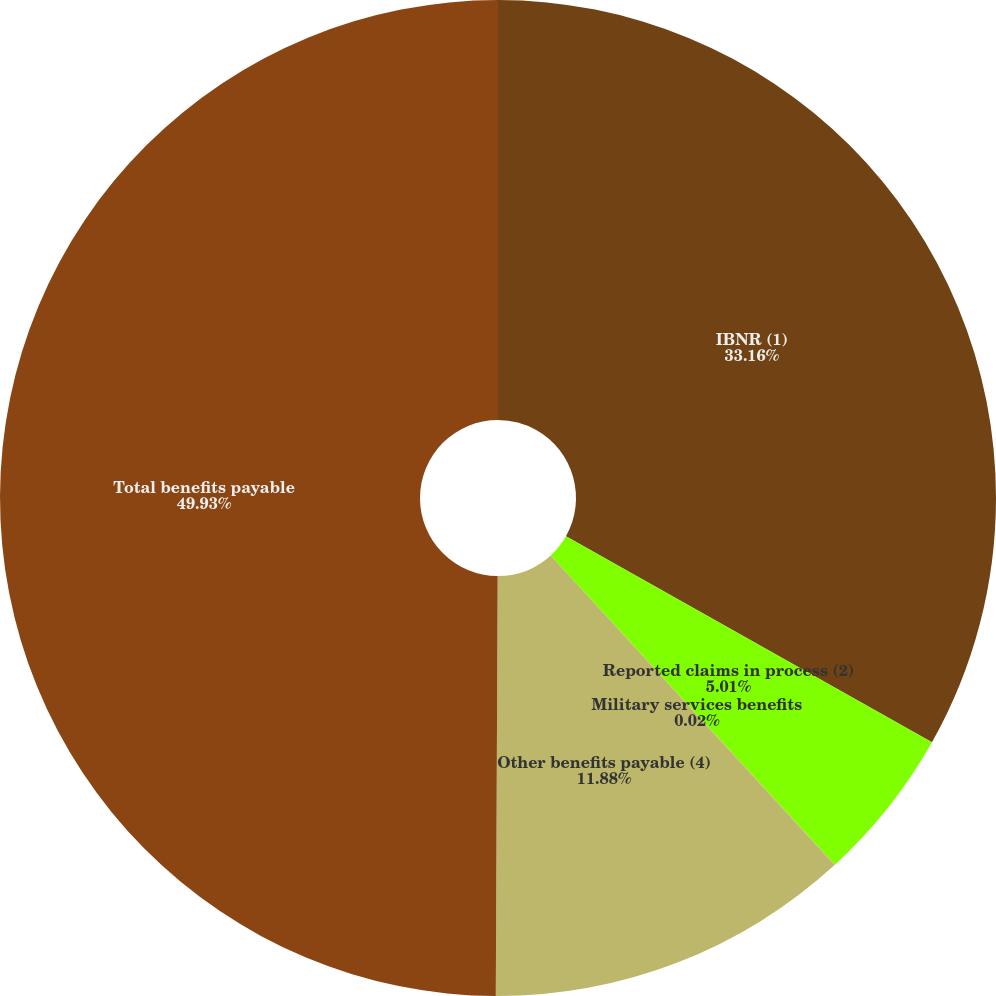Convert chart to OTSL. <chart><loc_0><loc_0><loc_500><loc_500><pie_chart><fcel>IBNR (1)<fcel>Reported claims in process (2)<fcel>Military services benefits<fcel>Other benefits payable (4)<fcel>Total benefits payable<nl><fcel>33.16%<fcel>5.01%<fcel>0.02%<fcel>11.88%<fcel>49.93%<nl></chart> 